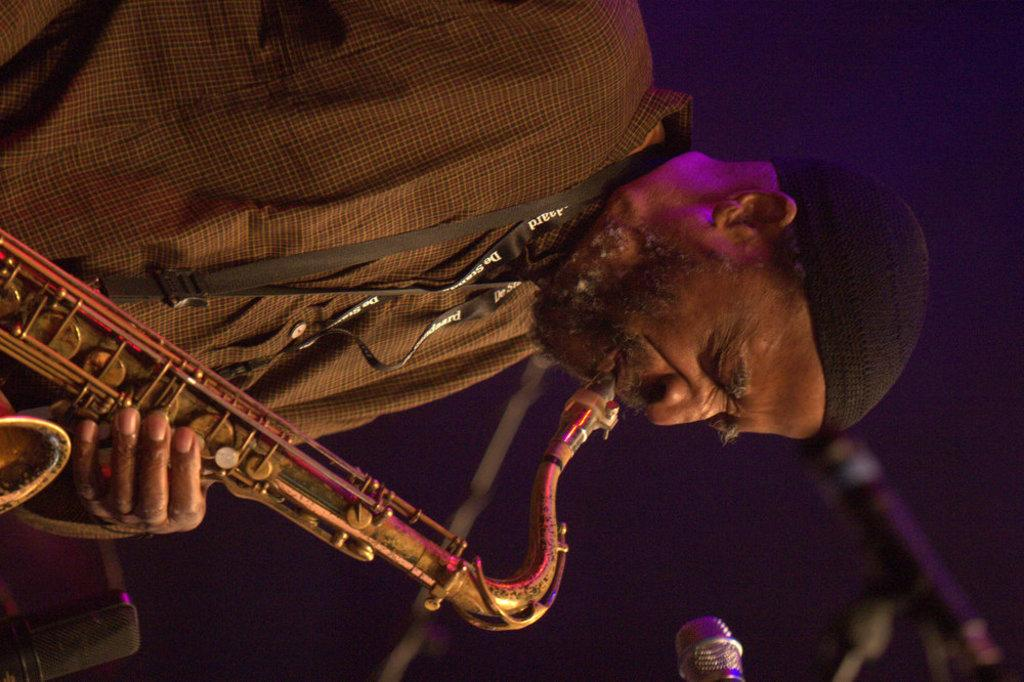What is the main subject of the image? There is a person in the image. What is the person doing in the image? The person is playing a musical instrument. What object is present in front of the person? There is a mic in front of the person. What type of appliance can be seen plugged into the wall in the image? There is no appliance plugged into the wall visible in the image. How many apples are on the table next to the person in the image? There are no apples present in the image. What is the person using to stop the flow of a liquid in the image? There is no cork or any object related to stopping the flow of a liquid present in the image. 